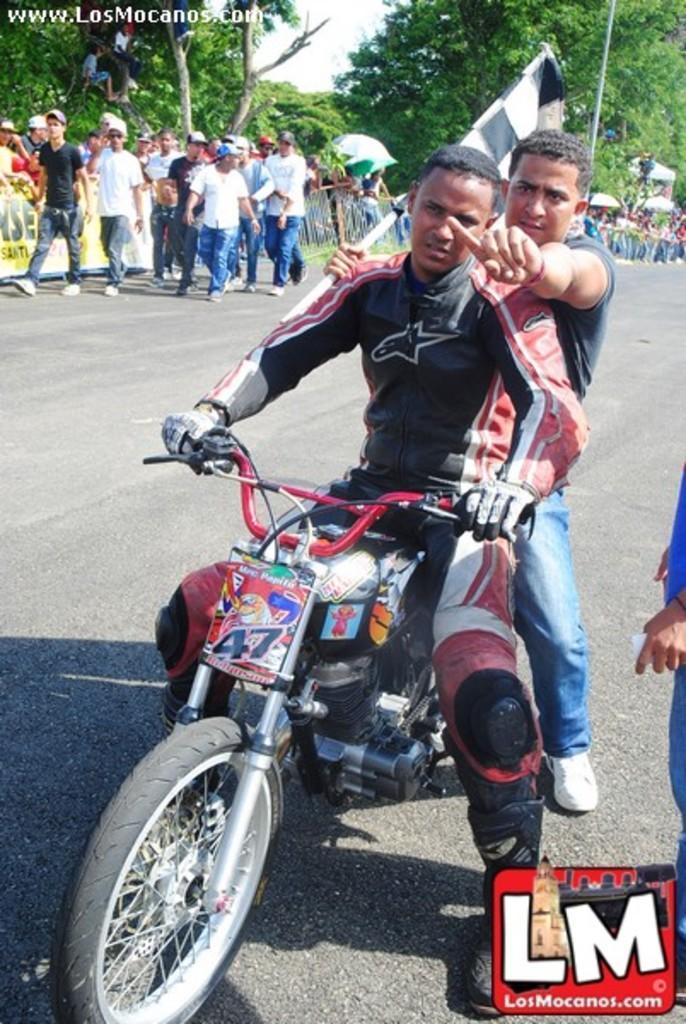Can you describe this image briefly? In the middle of the image two persons are riding motorcycle on the road. Behind them few people are walking on the road. At the top of the image there are some trees. 